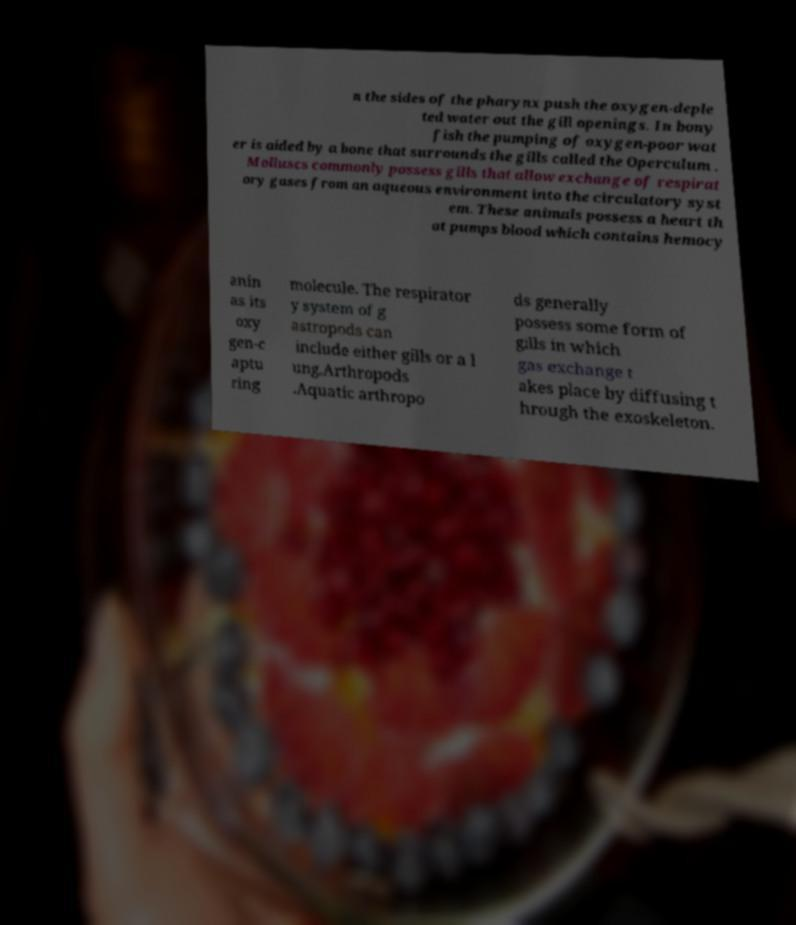Can you accurately transcribe the text from the provided image for me? n the sides of the pharynx push the oxygen-deple ted water out the gill openings. In bony fish the pumping of oxygen-poor wat er is aided by a bone that surrounds the gills called the Operculum . Molluscs commonly possess gills that allow exchange of respirat ory gases from an aqueous environment into the circulatory syst em. These animals possess a heart th at pumps blood which contains hemocy anin as its oxy gen-c aptu ring molecule. The respirator y system of g astropods can include either gills or a l ung.Arthropods .Aquatic arthropo ds generally possess some form of gills in which gas exchange t akes place by diffusing t hrough the exoskeleton. 